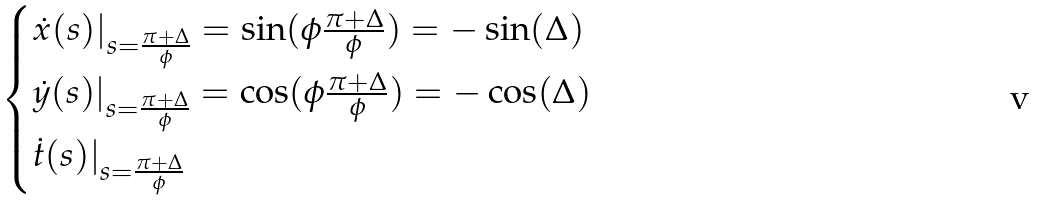<formula> <loc_0><loc_0><loc_500><loc_500>\begin{cases} \dot { x } ( s ) | _ { s = \frac { \pi + \Delta } { \phi } } = \sin ( \phi \frac { \pi + \Delta } { \phi } ) = - \sin ( \Delta ) \\ \dot { y } ( s ) | _ { s = \frac { \pi + \Delta } { \phi } } = \cos ( \phi \frac { \pi + \Delta } { \phi } ) = - \cos ( \Delta ) \\ \dot { t } ( s ) | _ { s = \frac { \pi + \Delta } { \phi } } \end{cases}</formula> 